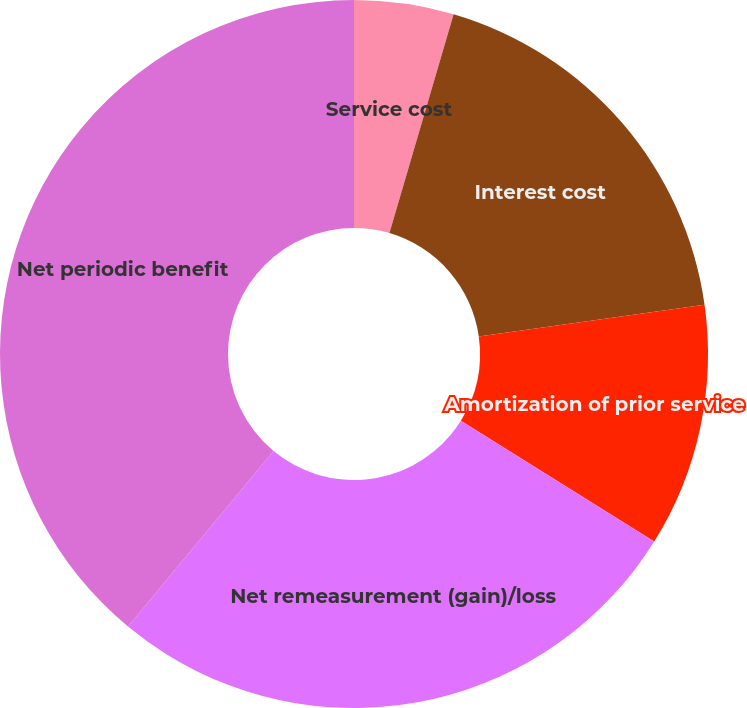<chart> <loc_0><loc_0><loc_500><loc_500><pie_chart><fcel>Service cost<fcel>Interest cost<fcel>Amortization of prior service<fcel>Net remeasurement (gain)/loss<fcel>Net periodic benefit<nl><fcel>4.54%<fcel>18.24%<fcel>11.11%<fcel>27.13%<fcel>38.98%<nl></chart> 